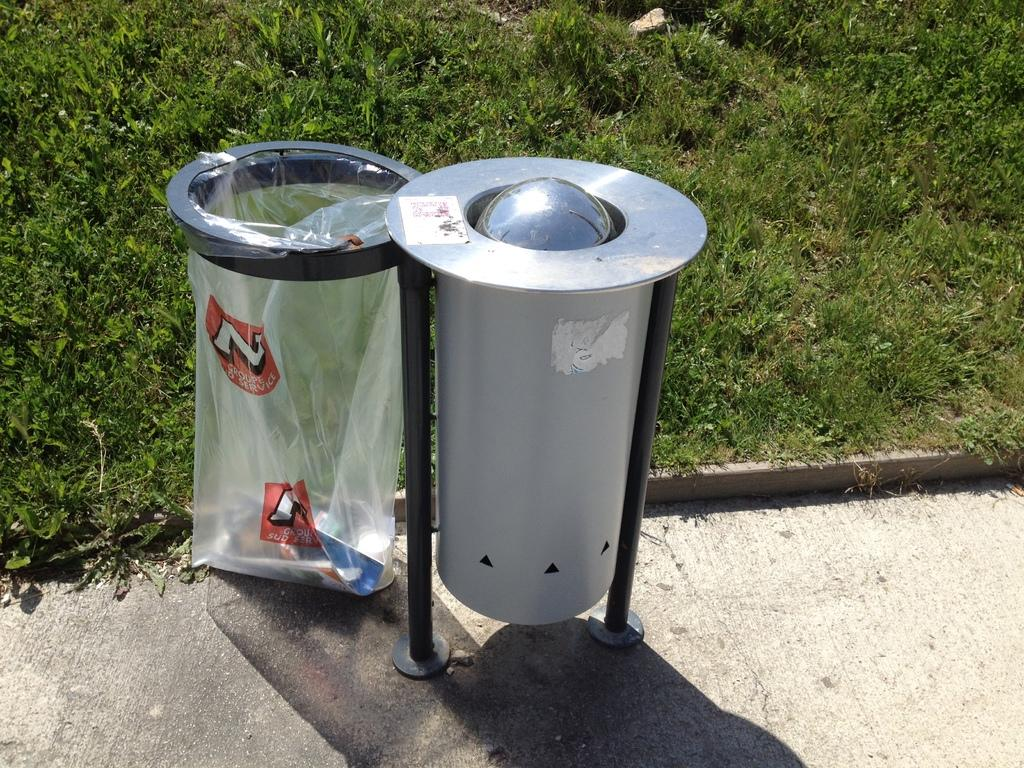Provide a one-sentence caption for the provided image. A trashbag outside of a trash can that says groupe sud service. 